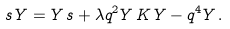<formula> <loc_0><loc_0><loc_500><loc_500>s \, Y = Y \, s + \lambda q ^ { 2 } Y \, K \, Y - q ^ { 4 } Y \, .</formula> 